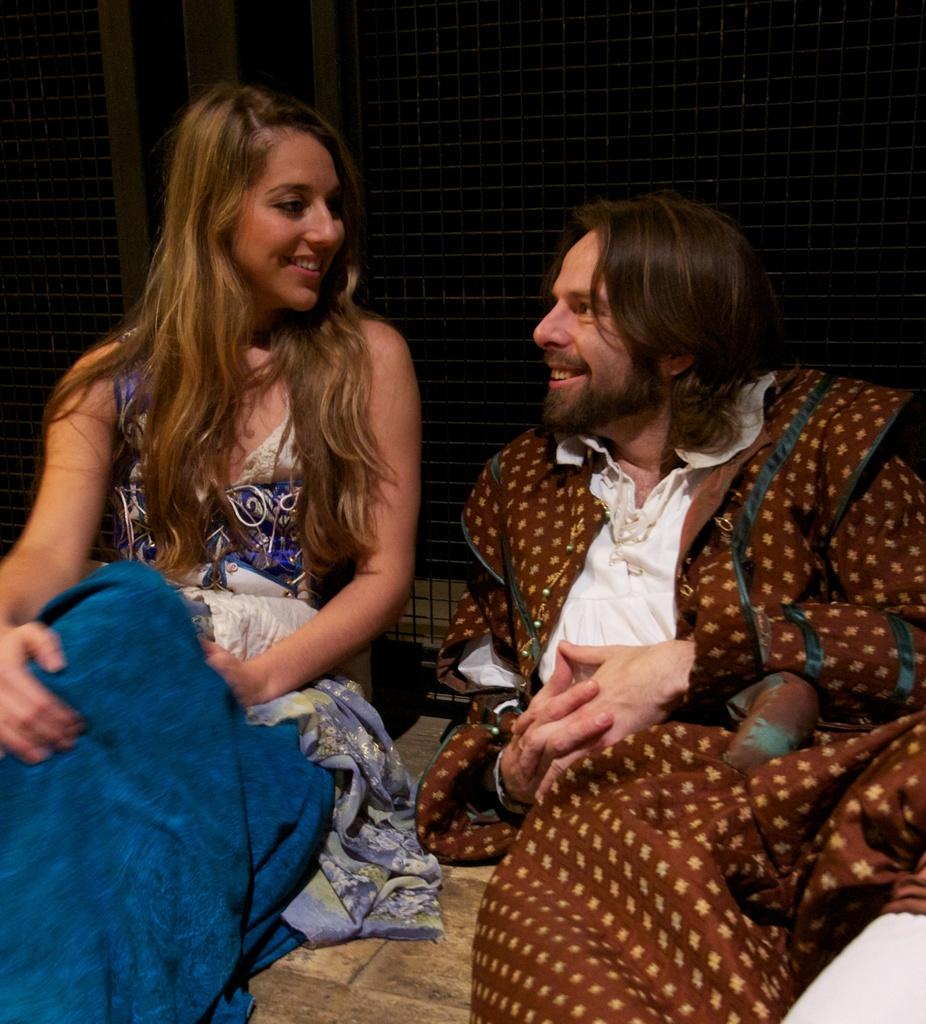Who are the people in the image? There is a man and a lady in the image. What are the man and the lady doing in the image? The man and the lady are sitting. What is the facial expression of the man and the lady in the image? The man and the lady are smiling. What type of quartz can be seen in the image? There is no quartz present in the image. How does the digestion of the man and the lady appear in the image? There is no indication of the man and the lady's digestion in the image. 